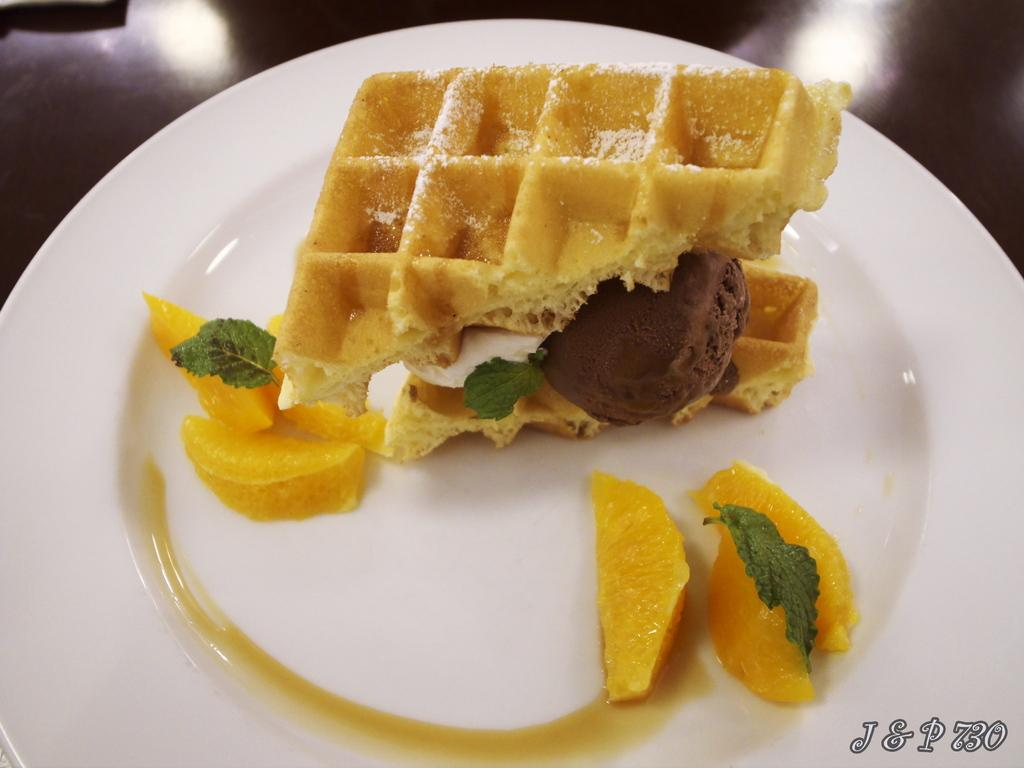What is on the plate in the image? There is a plate with food in the image. What type of pest can be seen crawling on the daughter's hair in the image? There is no daughter or pest present in the image; it only features a plate with food. 